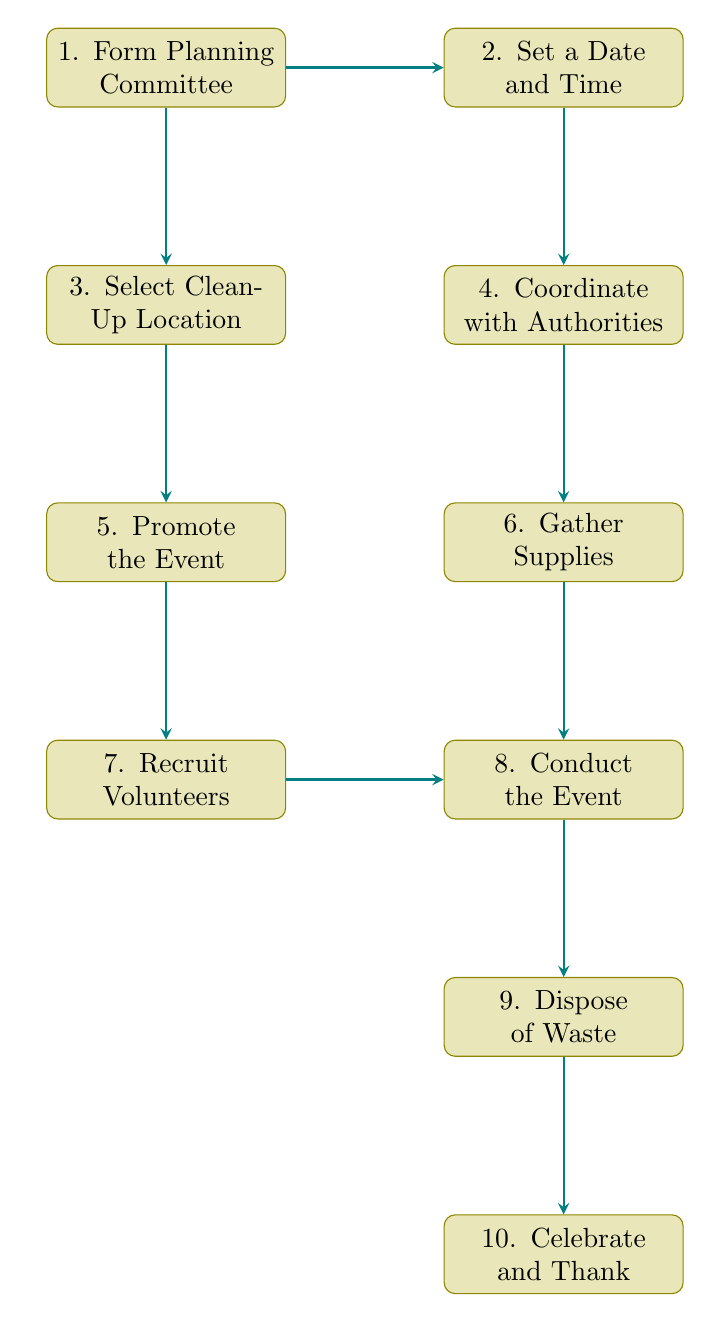What is the first step in organizing the event? The diagram clearly shows that the first node is "Form Planning Committee," indicating that this is the initial step in the process of organizing a community clean-up event.
Answer: Form Planning Committee How many nodes are in the flow chart? By counting each distinct process displayed in the diagram, we find that there are ten nodes that represent the steps involved in organizing the clean-up event.
Answer: 10 Which step follows "Gather Supplies"? The flow chart shows that after "Gather Supplies," the next step connected by an arrow is "Conduct the Event," indicating the sequence of actions.
Answer: Conduct the Event What step involves coordinating with local authorities? Referring to the flow diagram, "Coordinate with Local Authorities" is the specific node that addresses this action, positioned directly after the decision of setting a date and time.
Answer: Coordinate with Local Authorities What is the last step of the clean-up event process? The final node in the sequence, as depicted in the diagram, is "Celebrate and Thank Participants," which showcases the concluding action after all previous steps have been completed.
Answer: Celebrate and Thank Participants Which two steps occur simultaneously after forming the planning committee? The diagram illustrates that from the "Form Planning Committee" node, there are two arrows leading to "Set a Date and Time" and "Select Clean-Up Location," indicating these tasks are carried out concurrently.
Answer: Set a Date and Time, Select Clean-Up Location What is the purpose of the "Promote the Event" step? Looking at the diagram, this step is aimed at spreading the word about the festival to gain more participants, as shown by the description connected to the respective node in the flow.
Answer: Spread the word How many steps require interaction or coordination with others? Observing the diagram, the steps "Coordinate with Local Authorities," "Gather Supplies," "Recruit Volunteers," and "Dispose of Collected Waste" involve coordinating with external parties or community members, totaling four.
Answer: 4 